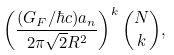<formula> <loc_0><loc_0><loc_500><loc_500>\left ( \frac { ( G _ { F } / \hbar { c } ) a _ { n } } { 2 \pi \sqrt { 2 } R ^ { 2 } } \right ) ^ { k } { N \choose k } ,</formula> 